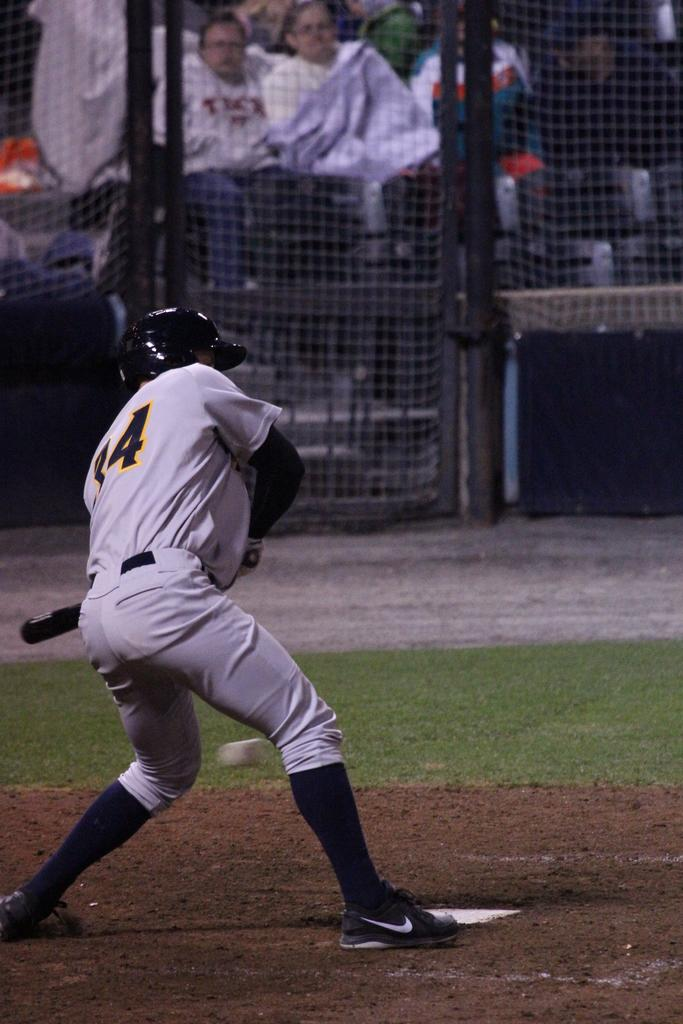<image>
Describe the image concisely. A baseball player wearing a jersey with the number 34 is about to hit a ball. 